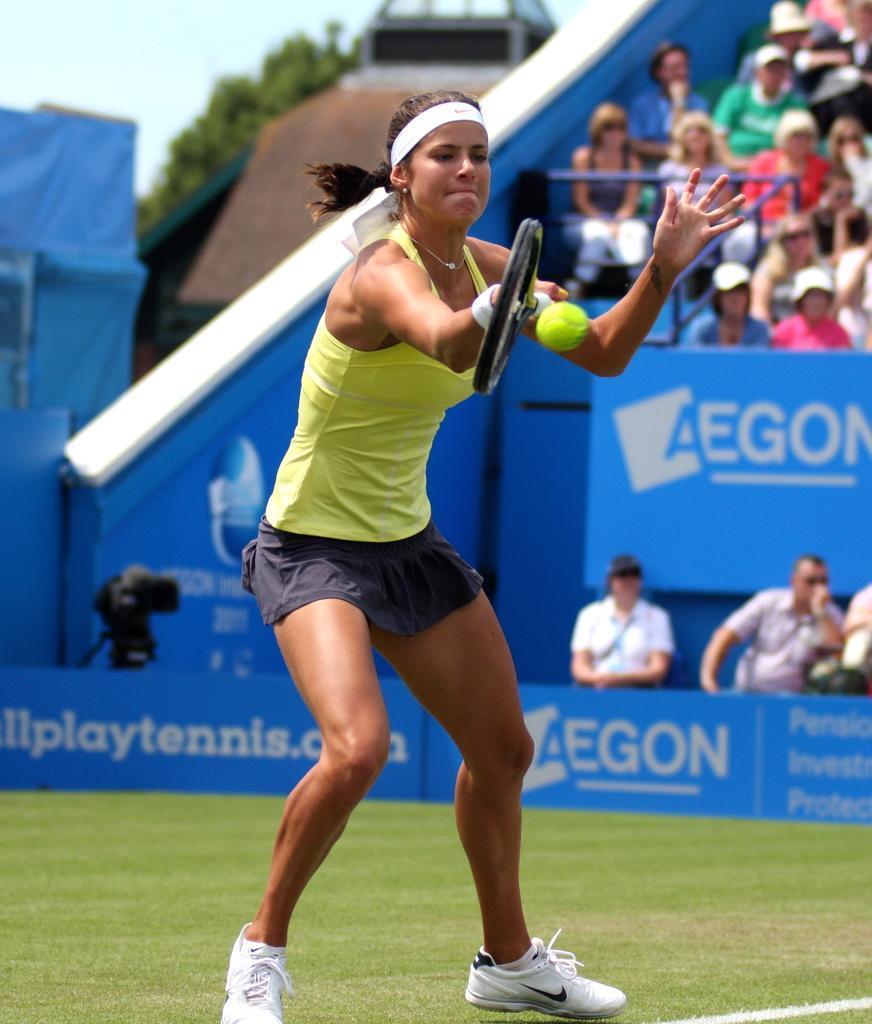In one or two sentences, can you explain what this image depicts? This is the picture of a stadium. In this image there is a person standing and holding the bat and there is a ball in the air. At the back there are group of people sitting in the stadium. On the left side of the image there is a camera. At the back there is a building and tree. At the top there is sky. At the bottom there is grass. 